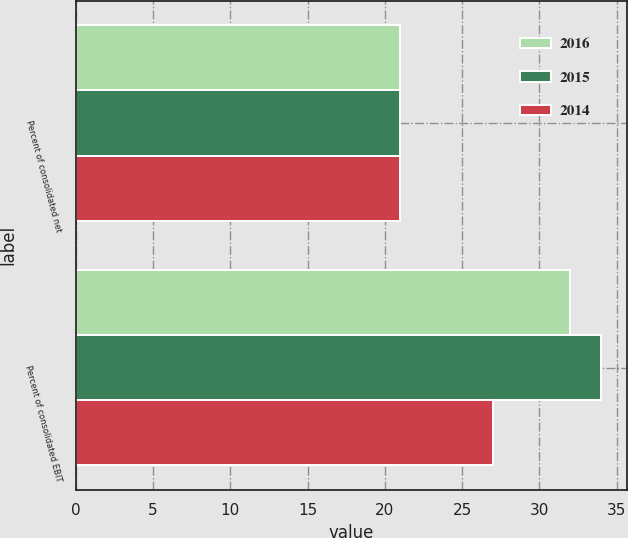Convert chart to OTSL. <chart><loc_0><loc_0><loc_500><loc_500><stacked_bar_chart><ecel><fcel>Percent of consolidated net<fcel>Percent of consolidated EBIT<nl><fcel>2016<fcel>21<fcel>32<nl><fcel>2015<fcel>21<fcel>34<nl><fcel>2014<fcel>21<fcel>27<nl></chart> 